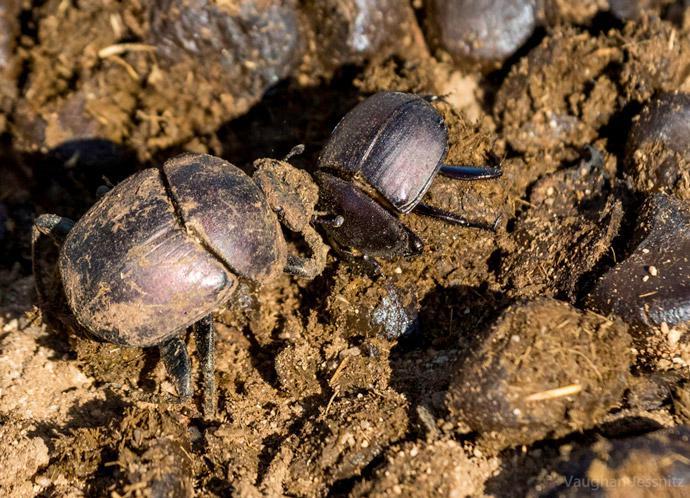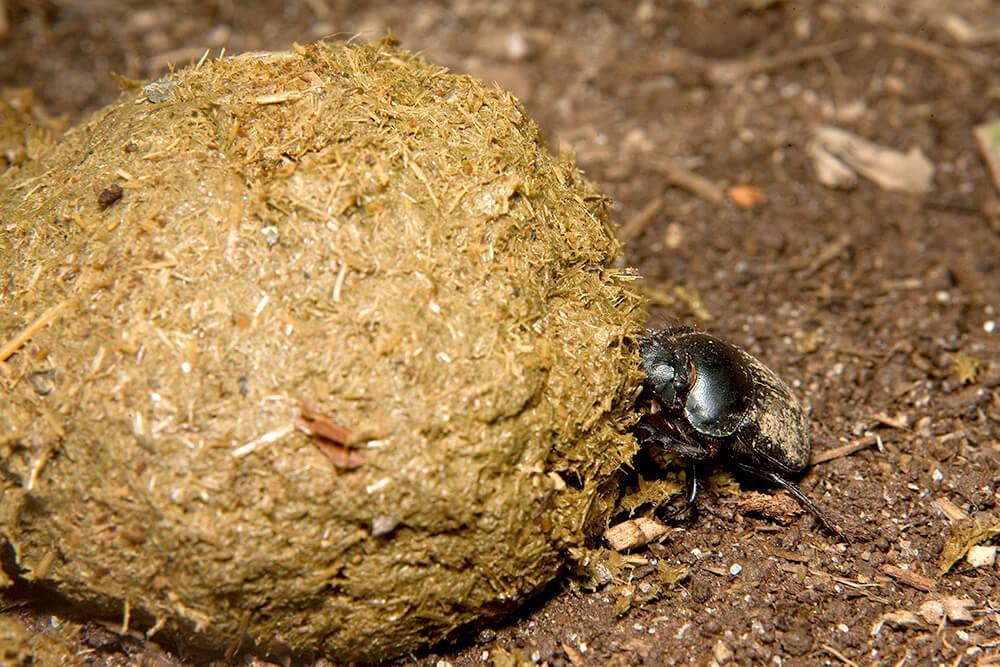The first image is the image on the left, the second image is the image on the right. Analyze the images presented: Is the assertion "Two beetles crawl across the ground." valid? Answer yes or no. No. The first image is the image on the left, the second image is the image on the right. Assess this claim about the two images: "An image shows one beetle in contact with one round dung ball.". Correct or not? Answer yes or no. Yes. 